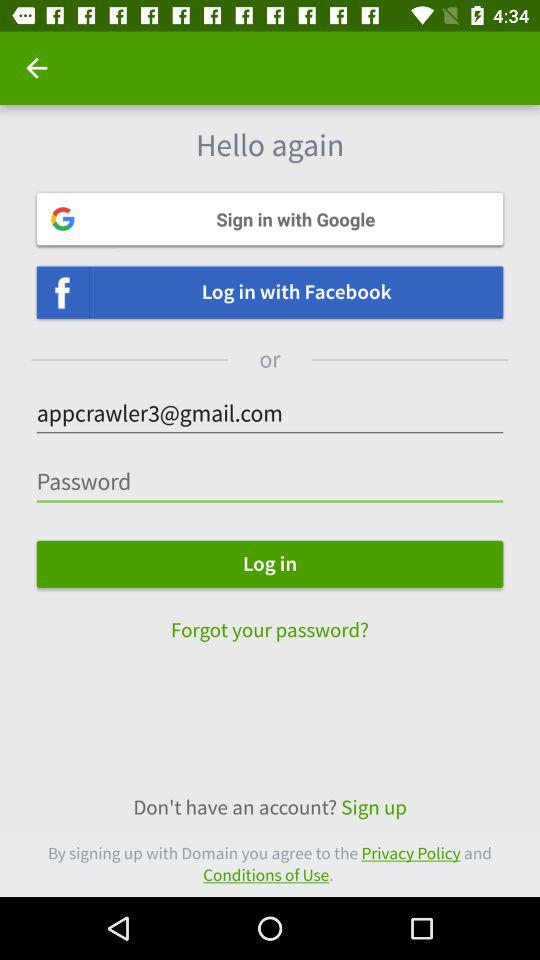What is the email id of the user? The email address is appcrawler3@gmail.com. 